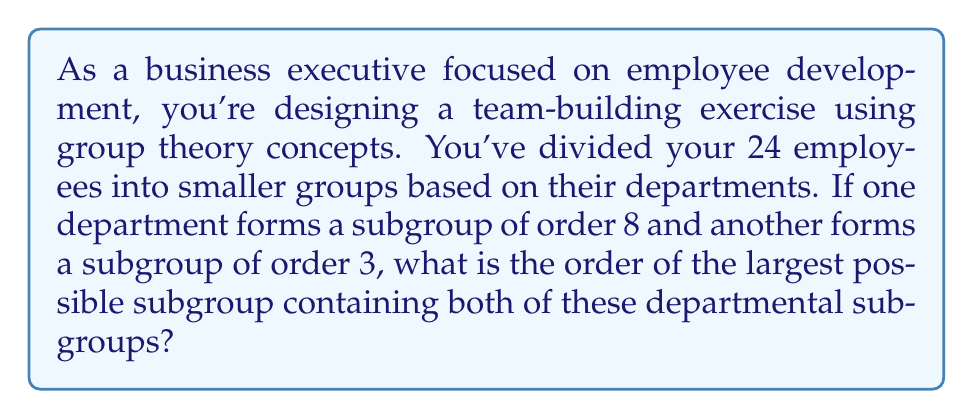Can you solve this math problem? To solve this problem, we need to apply the concept of the least common multiple (LCM) of subgroup orders. Let's break it down step-by-step:

1. We have a group $G$ of order 24 (representing all employees).
2. We have two subgroups:
   - Subgroup $H$ of order 8 (first department)
   - Subgroup $K$ of order 3 (second department)

3. We need to find the order of the largest subgroup $L$ that contains both $H$ and $K$.

4. The order of $L$ must be divisible by both 8 and 3, as it contains both subgroups.

5. The least common multiple (LCM) of 8 and 3 gives us the smallest number that is divisible by both:

   $LCM(8,3) = 24$

6. This means that the smallest subgroup containing both $H$ and $K$ would have order 24.

7. Since the original group $G$ has order 24, and 24 is the smallest possible order for a subgroup containing both $H$ and $K$, we conclude that $L = G$.

8. Therefore, the largest possible subgroup containing both departmental subgroups is the entire group $G$ of order 24.

This result aligns with the Lagrange's theorem in group theory, which states that the order of a subgroup must divide the order of the group. In this case, 24 is the smallest number divisible by both 8 and 3, and it happens to be the order of the entire group.
Answer: The order of the largest possible subgroup containing both departmental subgroups is 24. 